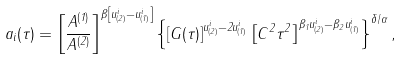Convert formula to latex. <formula><loc_0><loc_0><loc_500><loc_500>a _ { i } ( \tau ) = \left [ \frac { A ^ { ( 1 ) } } { A ^ { ( 2 ) } } \right ] ^ { \beta \left [ u _ { ( 2 ) } ^ { i } - u _ { ( 1 ) } ^ { i } \right ] } \left \{ \left [ G ( \tau ) \right ] ^ { u _ { ( 2 ) } ^ { i } - 2 u _ { ( 1 ) } ^ { i } } \left [ C ^ { 2 } \tau ^ { 2 } \right ] ^ { \beta _ { 1 } u _ { ( 2 ) } ^ { i } - \beta _ { 2 } u _ { ( 1 ) } ^ { i } } \right \} ^ { \delta / \alpha } ,</formula> 